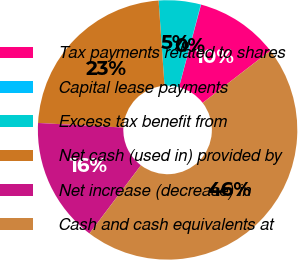<chart> <loc_0><loc_0><loc_500><loc_500><pie_chart><fcel>Tax payments related to shares<fcel>Capital lease payments<fcel>Excess tax benefit from<fcel>Net cash (used in) provided by<fcel>Net increase (decrease) in<fcel>Cash and cash equivalents at<nl><fcel>10.39%<fcel>0.04%<fcel>5.22%<fcel>23.04%<fcel>15.57%<fcel>45.74%<nl></chart> 